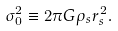Convert formula to latex. <formula><loc_0><loc_0><loc_500><loc_500>\sigma ^ { 2 } _ { 0 } \equiv 2 \pi G \rho _ { s } r ^ { 2 } _ { s } .</formula> 